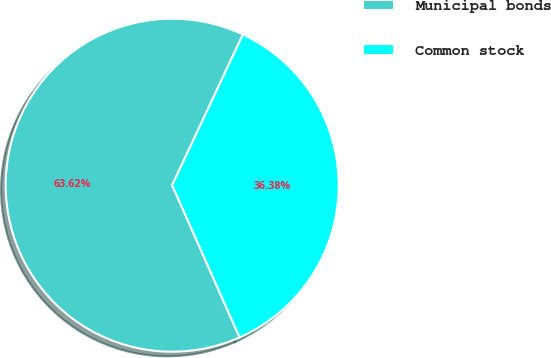<chart> <loc_0><loc_0><loc_500><loc_500><pie_chart><fcel>Municipal bonds<fcel>Common stock<nl><fcel>63.62%<fcel>36.38%<nl></chart> 